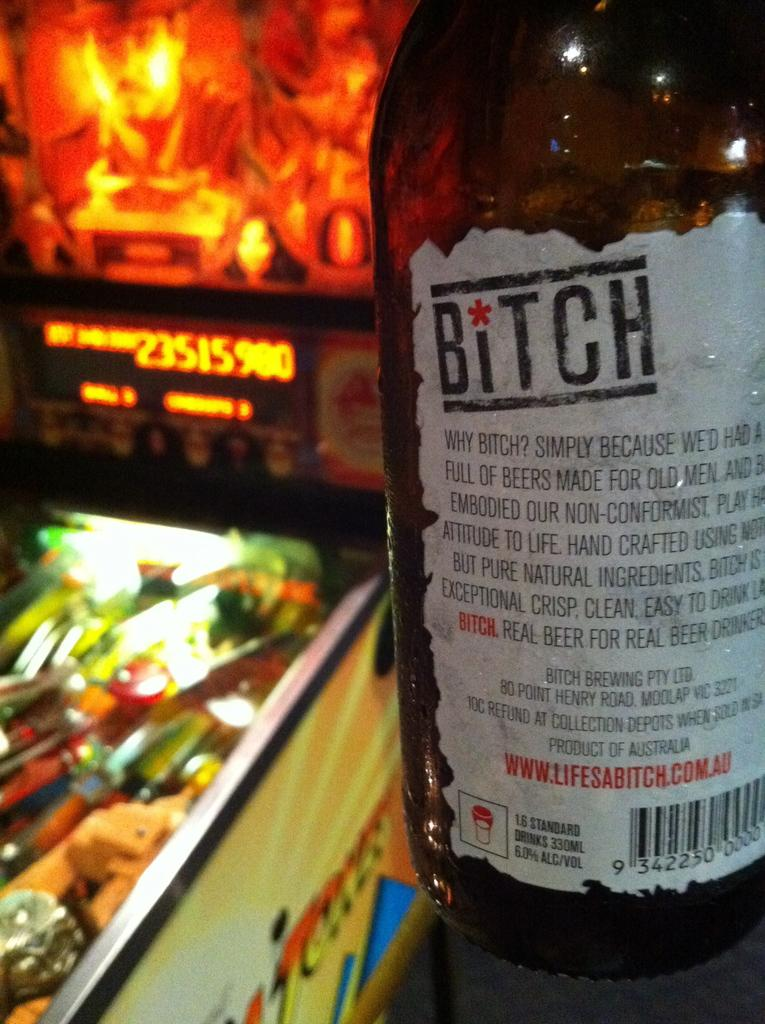<image>
Present a compact description of the photo's key features. A pin ball machine displays a score of 21515900 in orange lights. 